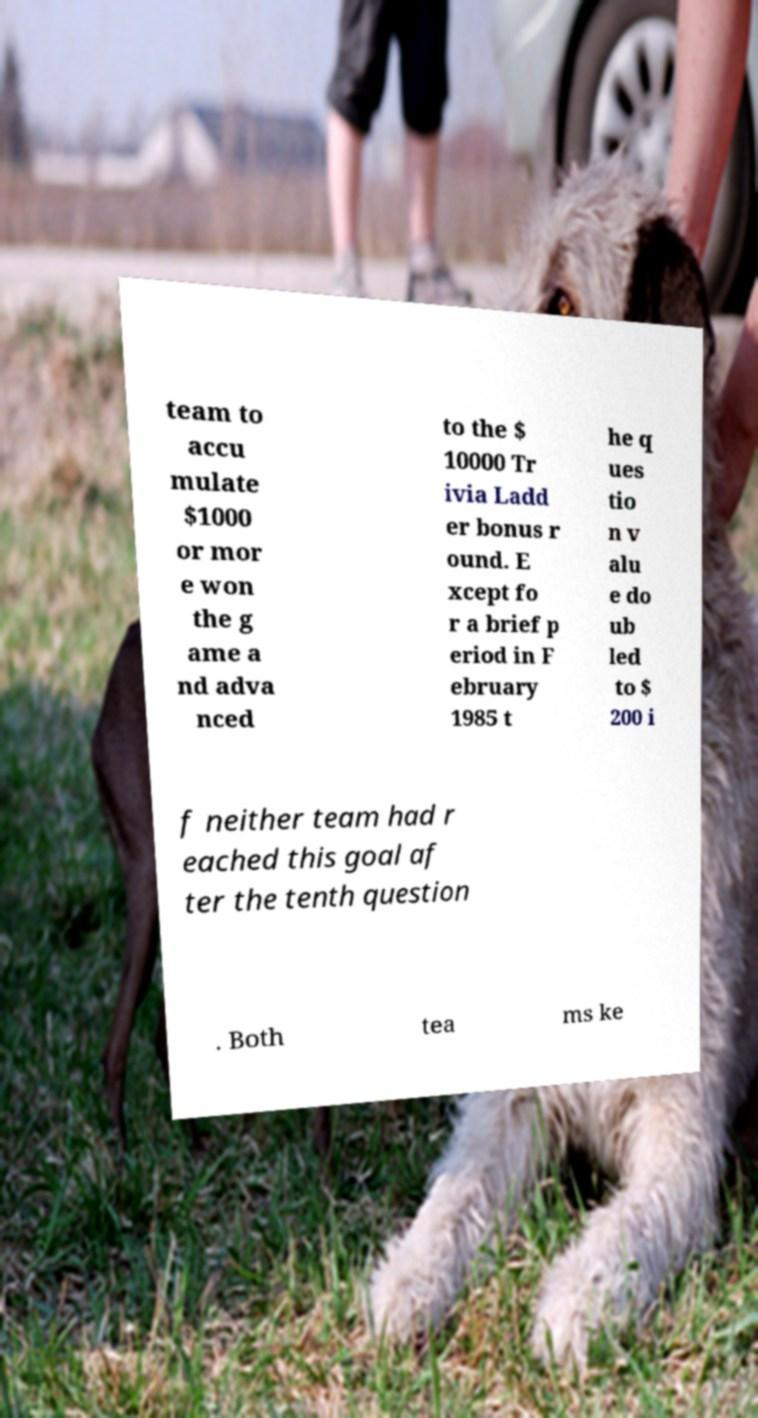For documentation purposes, I need the text within this image transcribed. Could you provide that? team to accu mulate $1000 or mor e won the g ame a nd adva nced to the $ 10000 Tr ivia Ladd er bonus r ound. E xcept fo r a brief p eriod in F ebruary 1985 t he q ues tio n v alu e do ub led to $ 200 i f neither team had r eached this goal af ter the tenth question . Both tea ms ke 